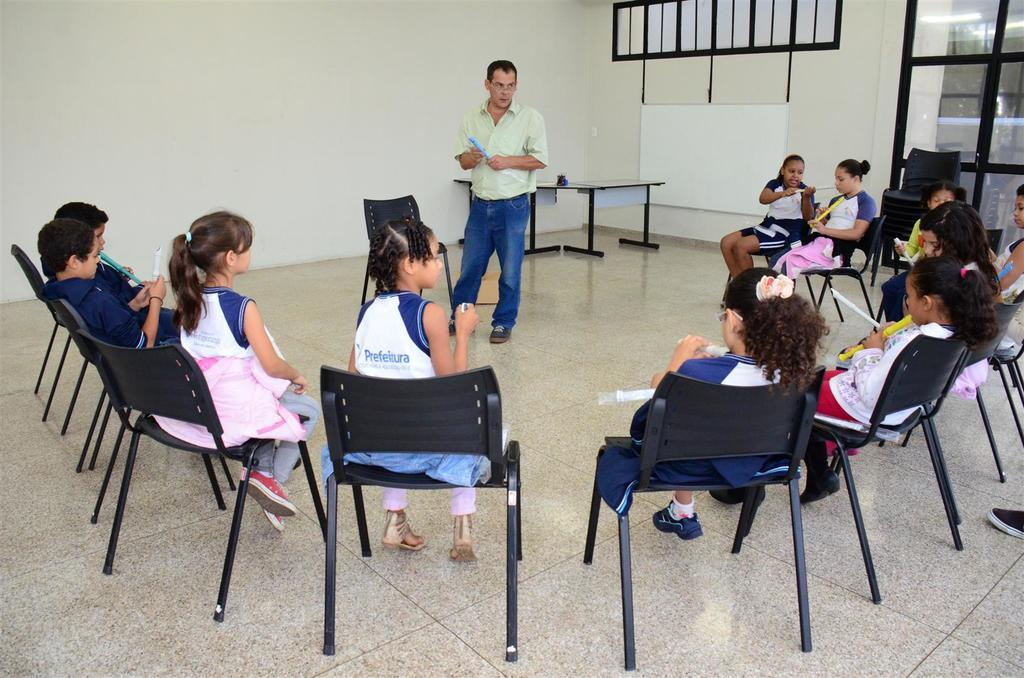What can be seen in the image? There are kids and a man in the image. What are the kids doing in the image? The kids are sitting on chairs in the image. What is the man doing in the image? The man is standing and looking at the kids in the image. What type of test is being conducted in the image? There is no test being conducted in the image; it simply shows kids sitting on chairs and a man standing nearby. Can you see any caves or cherry trees in the image? No, there are no caves or cherry trees present in the image. 